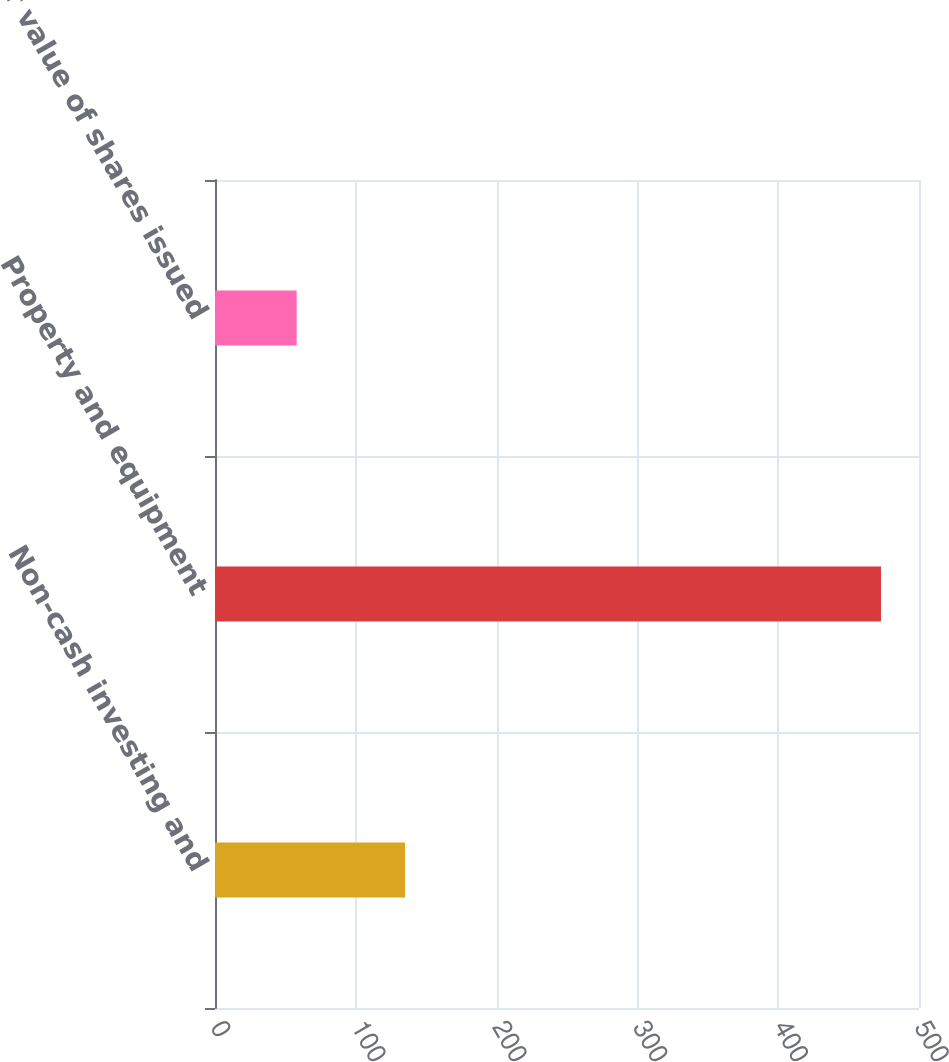Convert chart. <chart><loc_0><loc_0><loc_500><loc_500><bar_chart><fcel>Non-cash investing and<fcel>Property and equipment<fcel>Fair value of shares issued<nl><fcel>135<fcel>473<fcel>58<nl></chart> 